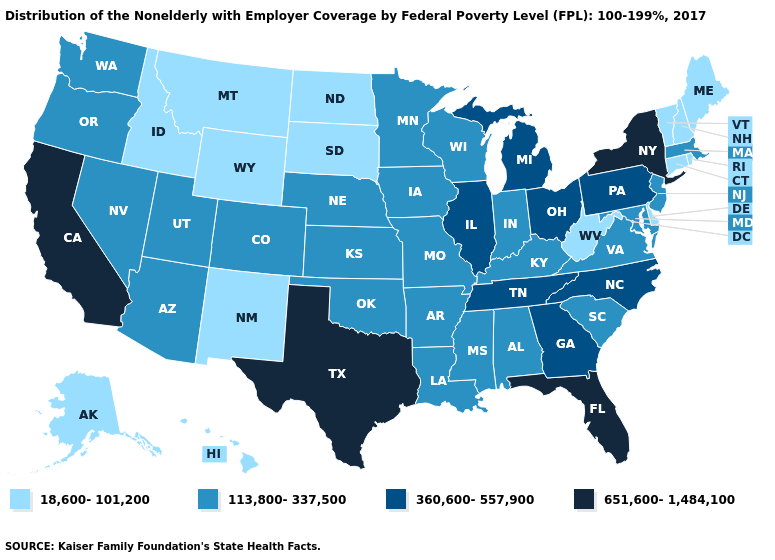Does California have the highest value in the West?
Keep it brief. Yes. Does Alabama have a higher value than Tennessee?
Be succinct. No. Does New York have the highest value in the USA?
Short answer required. Yes. What is the value of New York?
Keep it brief. 651,600-1,484,100. Which states have the lowest value in the USA?
Answer briefly. Alaska, Connecticut, Delaware, Hawaii, Idaho, Maine, Montana, New Hampshire, New Mexico, North Dakota, Rhode Island, South Dakota, Vermont, West Virginia, Wyoming. What is the value of Oklahoma?
Concise answer only. 113,800-337,500. What is the value of Nebraska?
Be succinct. 113,800-337,500. What is the value of Nebraska?
Write a very short answer. 113,800-337,500. Which states have the highest value in the USA?
Short answer required. California, Florida, New York, Texas. Among the states that border North Dakota , does South Dakota have the lowest value?
Give a very brief answer. Yes. What is the value of Florida?
Give a very brief answer. 651,600-1,484,100. Among the states that border Georgia , which have the lowest value?
Short answer required. Alabama, South Carolina. What is the value of West Virginia?
Write a very short answer. 18,600-101,200. What is the value of Indiana?
Keep it brief. 113,800-337,500. What is the highest value in the Northeast ?
Quick response, please. 651,600-1,484,100. 